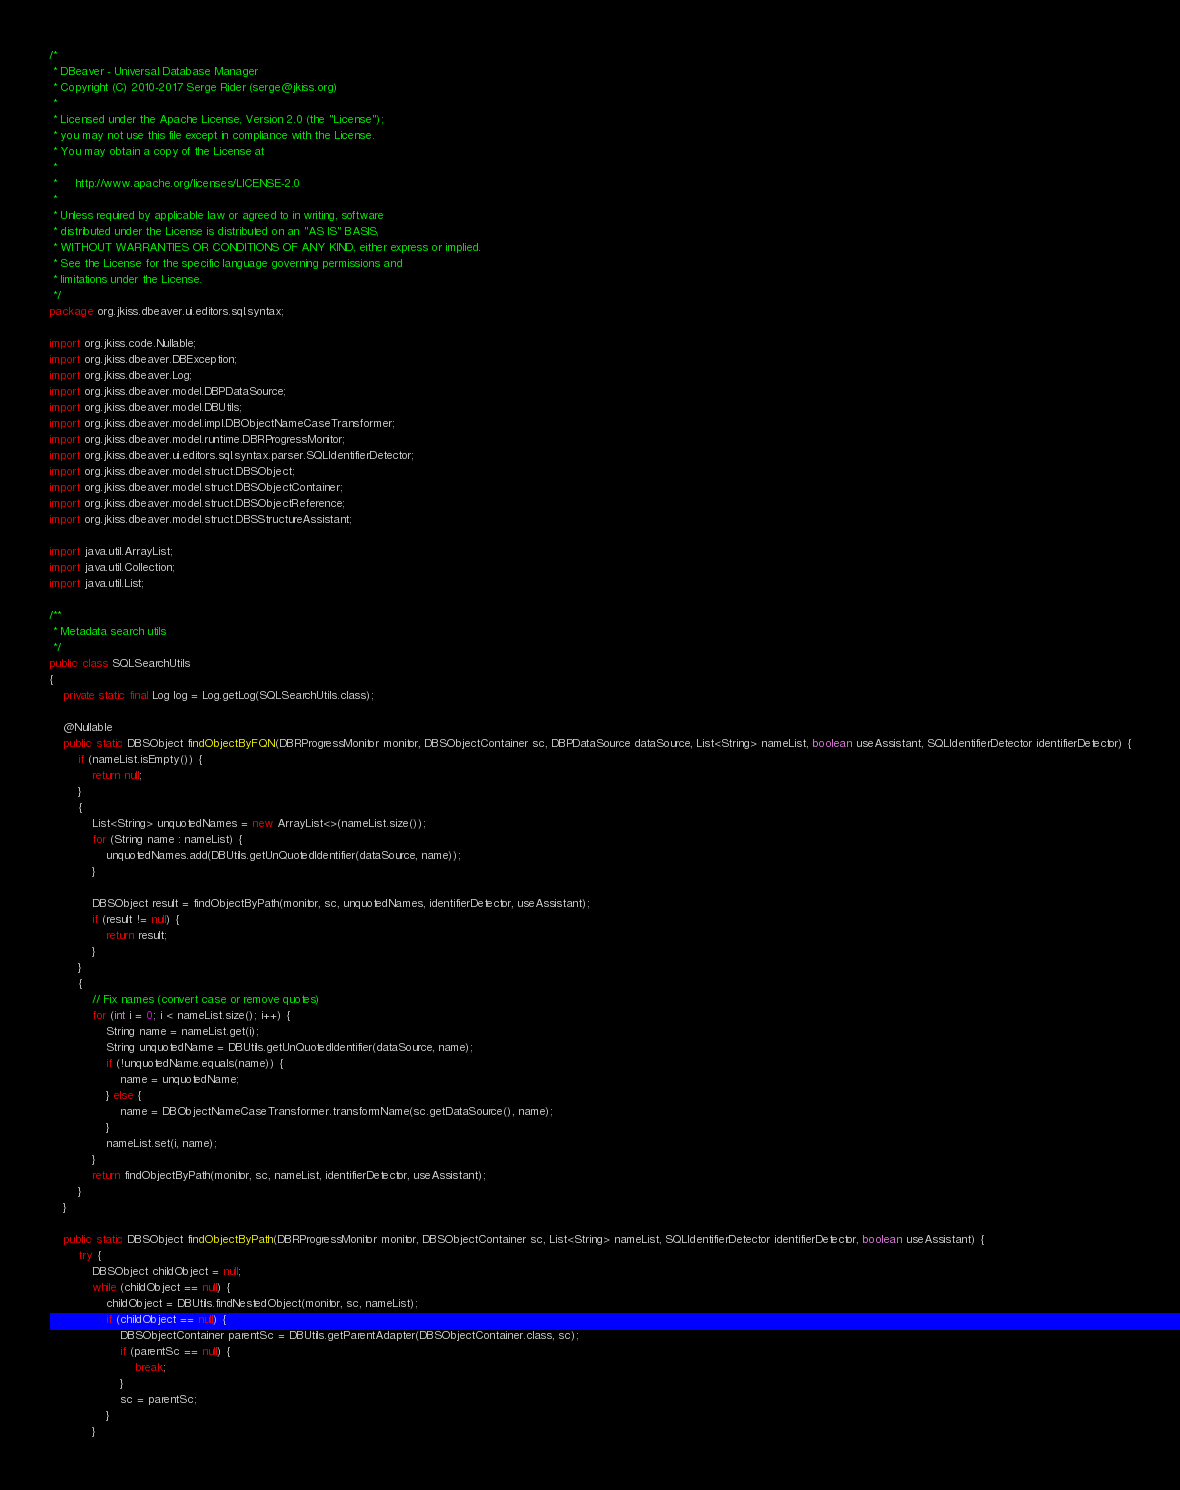<code> <loc_0><loc_0><loc_500><loc_500><_Java_>/*
 * DBeaver - Universal Database Manager
 * Copyright (C) 2010-2017 Serge Rider (serge@jkiss.org)
 *
 * Licensed under the Apache License, Version 2.0 (the "License");
 * you may not use this file except in compliance with the License.
 * You may obtain a copy of the License at
 *
 *     http://www.apache.org/licenses/LICENSE-2.0
 *
 * Unless required by applicable law or agreed to in writing, software
 * distributed under the License is distributed on an "AS IS" BASIS,
 * WITHOUT WARRANTIES OR CONDITIONS OF ANY KIND, either express or implied.
 * See the License for the specific language governing permissions and
 * limitations under the License.
 */
package org.jkiss.dbeaver.ui.editors.sql.syntax;

import org.jkiss.code.Nullable;
import org.jkiss.dbeaver.DBException;
import org.jkiss.dbeaver.Log;
import org.jkiss.dbeaver.model.DBPDataSource;
import org.jkiss.dbeaver.model.DBUtils;
import org.jkiss.dbeaver.model.impl.DBObjectNameCaseTransformer;
import org.jkiss.dbeaver.model.runtime.DBRProgressMonitor;
import org.jkiss.dbeaver.ui.editors.sql.syntax.parser.SQLIdentifierDetector;
import org.jkiss.dbeaver.model.struct.DBSObject;
import org.jkiss.dbeaver.model.struct.DBSObjectContainer;
import org.jkiss.dbeaver.model.struct.DBSObjectReference;
import org.jkiss.dbeaver.model.struct.DBSStructureAssistant;

import java.util.ArrayList;
import java.util.Collection;
import java.util.List;

/**
 * Metadata search utils
 */
public class SQLSearchUtils
{
    private static final Log log = Log.getLog(SQLSearchUtils.class);

    @Nullable
    public static DBSObject findObjectByFQN(DBRProgressMonitor monitor, DBSObjectContainer sc, DBPDataSource dataSource, List<String> nameList, boolean useAssistant, SQLIdentifierDetector identifierDetector) {
        if (nameList.isEmpty()) {
            return null;
        }
        {
            List<String> unquotedNames = new ArrayList<>(nameList.size());
            for (String name : nameList) {
                unquotedNames.add(DBUtils.getUnQuotedIdentifier(dataSource, name));
            }

            DBSObject result = findObjectByPath(monitor, sc, unquotedNames, identifierDetector, useAssistant);
            if (result != null) {
                return result;
            }
        }
        {
            // Fix names (convert case or remove quotes)
            for (int i = 0; i < nameList.size(); i++) {
                String name = nameList.get(i);
                String unquotedName = DBUtils.getUnQuotedIdentifier(dataSource, name);
                if (!unquotedName.equals(name)) {
                    name = unquotedName;
                } else {
                    name = DBObjectNameCaseTransformer.transformName(sc.getDataSource(), name);
                }
                nameList.set(i, name);
            }
            return findObjectByPath(monitor, sc, nameList, identifierDetector, useAssistant);
        }
    }

    public static DBSObject findObjectByPath(DBRProgressMonitor monitor, DBSObjectContainer sc, List<String> nameList, SQLIdentifierDetector identifierDetector, boolean useAssistant) {
        try {
            DBSObject childObject = null;
            while (childObject == null) {
                childObject = DBUtils.findNestedObject(monitor, sc, nameList);
                if (childObject == null) {
                    DBSObjectContainer parentSc = DBUtils.getParentAdapter(DBSObjectContainer.class, sc);
                    if (parentSc == null) {
                        break;
                    }
                    sc = parentSc;
                }
            }</code> 